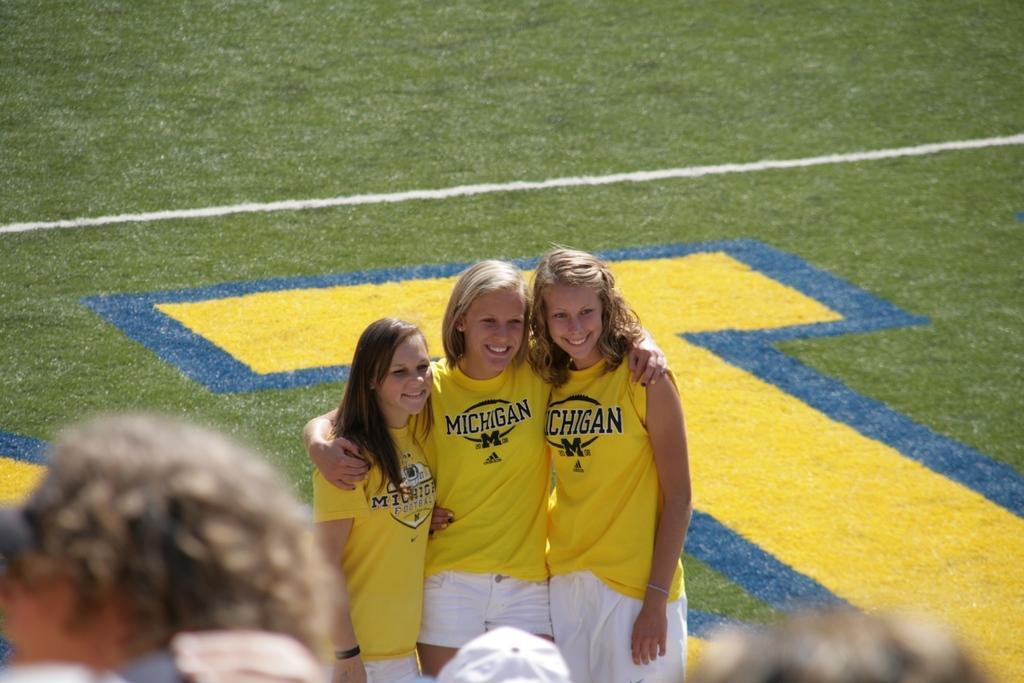Please provide a concise description of this image. In the center of the image we can see three people standing and smiling. At the bottom there are people. In the background we can see a field. 